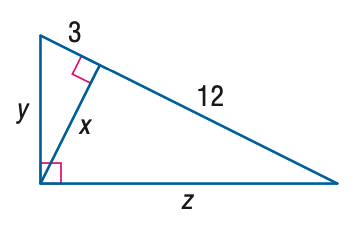Answer the mathemtical geometry problem and directly provide the correct option letter.
Question: Find x.
Choices: A: 3 B: 4 C: 6 D: 12 C 